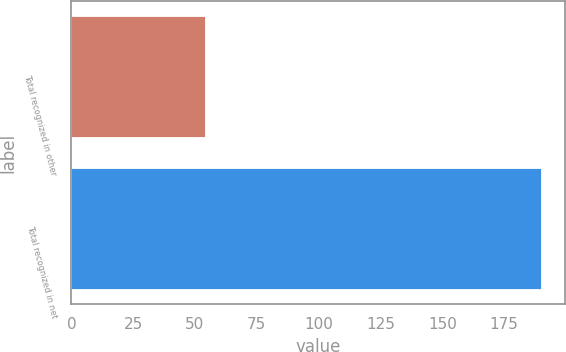<chart> <loc_0><loc_0><loc_500><loc_500><bar_chart><fcel>Total recognized in other<fcel>Total recognized in net<nl><fcel>54<fcel>190<nl></chart> 